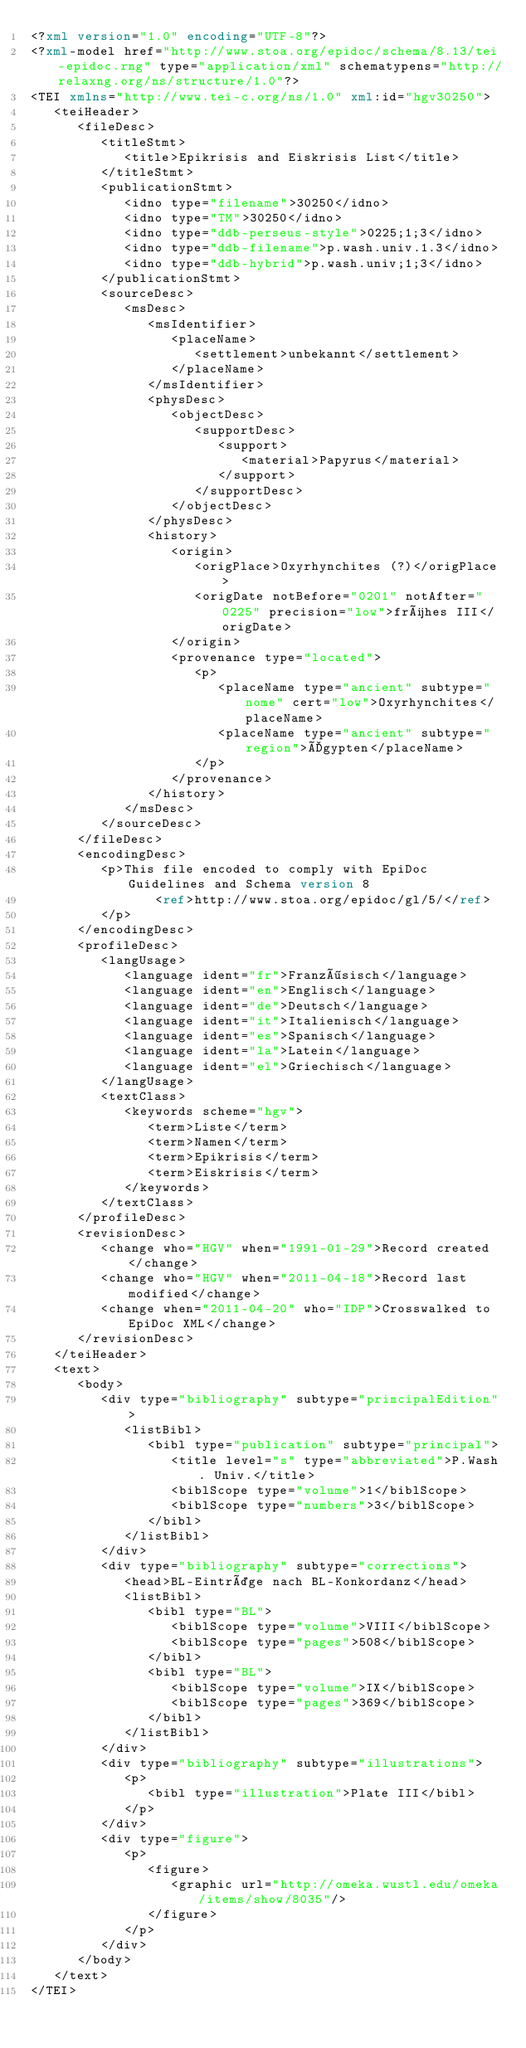<code> <loc_0><loc_0><loc_500><loc_500><_XML_><?xml version="1.0" encoding="UTF-8"?>
<?xml-model href="http://www.stoa.org/epidoc/schema/8.13/tei-epidoc.rng" type="application/xml" schematypens="http://relaxng.org/ns/structure/1.0"?>
<TEI xmlns="http://www.tei-c.org/ns/1.0" xml:id="hgv30250">
   <teiHeader>
      <fileDesc>
         <titleStmt>
            <title>Epikrisis and Eiskrisis List</title>
         </titleStmt>
         <publicationStmt>
            <idno type="filename">30250</idno>
            <idno type="TM">30250</idno>
            <idno type="ddb-perseus-style">0225;1;3</idno>
            <idno type="ddb-filename">p.wash.univ.1.3</idno>
            <idno type="ddb-hybrid">p.wash.univ;1;3</idno>
         </publicationStmt>
         <sourceDesc>
            <msDesc>
               <msIdentifier>
                  <placeName>
                     <settlement>unbekannt</settlement>
                  </placeName>
               </msIdentifier>
               <physDesc>
                  <objectDesc>
                     <supportDesc>
                        <support>
                           <material>Papyrus</material>
                        </support>
                     </supportDesc>
                  </objectDesc>
               </physDesc>
               <history>
                  <origin>
                     <origPlace>Oxyrhynchites (?)</origPlace>
                     <origDate notBefore="0201" notAfter="0225" precision="low">frühes III</origDate>
                  </origin>
                  <provenance type="located">
                     <p>
                        <placeName type="ancient" subtype="nome" cert="low">Oxyrhynchites</placeName>
                        <placeName type="ancient" subtype="region">Ägypten</placeName>
                     </p>
                  </provenance>
               </history>
            </msDesc>
         </sourceDesc>
      </fileDesc>
      <encodingDesc>
         <p>This file encoded to comply with EpiDoc Guidelines and Schema version 8
                <ref>http://www.stoa.org/epidoc/gl/5/</ref>
         </p>
      </encodingDesc>
      <profileDesc>
         <langUsage>
            <language ident="fr">Französisch</language>
            <language ident="en">Englisch</language>
            <language ident="de">Deutsch</language>
            <language ident="it">Italienisch</language>
            <language ident="es">Spanisch</language>
            <language ident="la">Latein</language>
            <language ident="el">Griechisch</language>
         </langUsage>
         <textClass>
            <keywords scheme="hgv">
               <term>Liste</term>
               <term>Namen</term>
               <term>Epikrisis</term>
               <term>Eiskrisis</term>
            </keywords>
         </textClass>
      </profileDesc>
      <revisionDesc>
         <change who="HGV" when="1991-01-29">Record created</change>
         <change who="HGV" when="2011-04-18">Record last modified</change>
         <change when="2011-04-20" who="IDP">Crosswalked to EpiDoc XML</change>
      </revisionDesc>
   </teiHeader>
   <text>
      <body>
         <div type="bibliography" subtype="principalEdition">
            <listBibl>
               <bibl type="publication" subtype="principal">
                  <title level="s" type="abbreviated">P.Wash. Univ.</title>
                  <biblScope type="volume">1</biblScope>
                  <biblScope type="numbers">3</biblScope>
               </bibl>
            </listBibl>
         </div>
         <div type="bibliography" subtype="corrections">
            <head>BL-Einträge nach BL-Konkordanz</head>
            <listBibl>
               <bibl type="BL">
                  <biblScope type="volume">VIII</biblScope>
                  <biblScope type="pages">508</biblScope>
               </bibl>
               <bibl type="BL">
                  <biblScope type="volume">IX</biblScope>
                  <biblScope type="pages">369</biblScope>
               </bibl>
            </listBibl>
         </div>
         <div type="bibliography" subtype="illustrations">
            <p>
               <bibl type="illustration">Plate III</bibl>
            </p>
         </div>
         <div type="figure">
            <p>
               <figure>
                  <graphic url="http://omeka.wustl.edu/omeka/items/show/8035"/>
               </figure>
            </p>
         </div>
      </body>
   </text>
</TEI>
</code> 